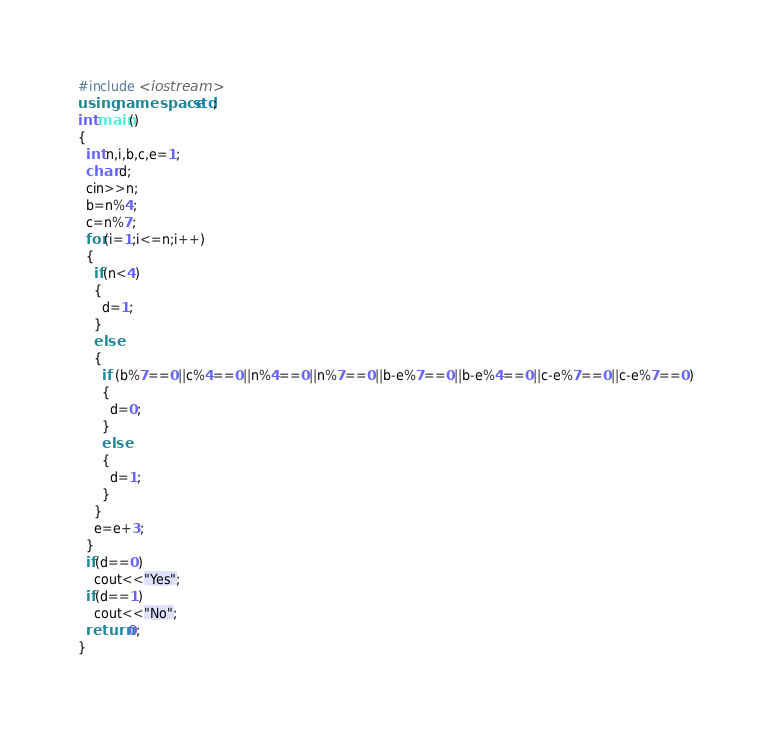Convert code to text. <code><loc_0><loc_0><loc_500><loc_500><_C++_>#include <iostream>
using namespace std;
int main()
{
  int n,i,b,c,e=1;
  char d;
  cin>>n;
  b=n%4;
  c=n%7;
  for(i=1;i<=n;i++)
  {
    if(n<4)
    {
      d=1;
    }
    else
    {
      if (b%7==0||c%4==0||n%4==0||n%7==0||b-e%7==0||b-e%4==0||c-e%7==0||c-e%7==0)
      {
        d=0;
      }
      else
      {
        d=1;
      }
    }
    e=e+3;
  }
  if(d==0)
    cout<<"Yes";
  if(d==1)
    cout<<"No";
  return 0;
}
</code> 